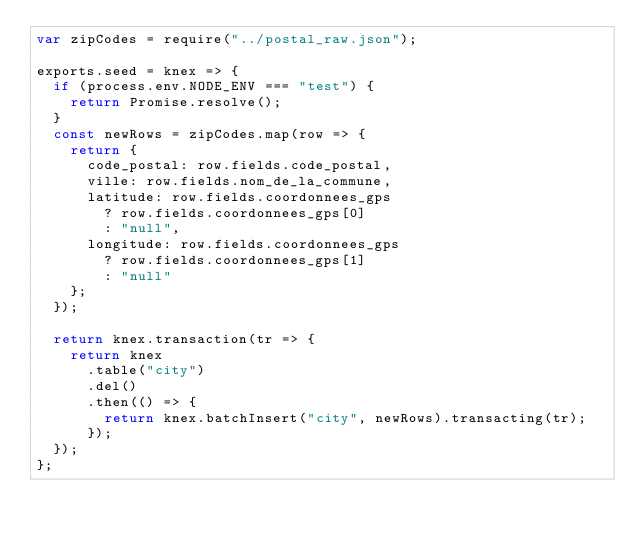Convert code to text. <code><loc_0><loc_0><loc_500><loc_500><_JavaScript_>var zipCodes = require("../postal_raw.json");

exports.seed = knex => {
  if (process.env.NODE_ENV === "test") {
    return Promise.resolve();
  }
  const newRows = zipCodes.map(row => {
    return {
      code_postal: row.fields.code_postal,
      ville: row.fields.nom_de_la_commune,
      latitude: row.fields.coordonnees_gps
        ? row.fields.coordonnees_gps[0]
        : "null",
      longitude: row.fields.coordonnees_gps
        ? row.fields.coordonnees_gps[1]
        : "null"
    };
  });

  return knex.transaction(tr => {
    return knex
      .table("city")
      .del()
      .then(() => {
        return knex.batchInsert("city", newRows).transacting(tr);
      });
  });
};
</code> 